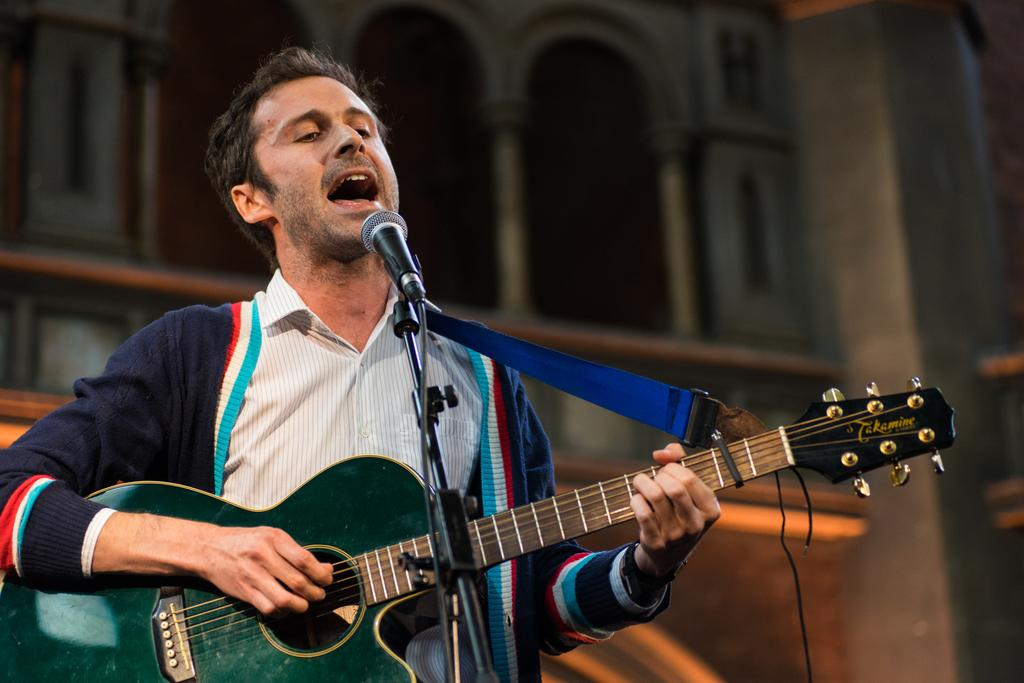Who is present in the image? There is a man in the image. What is the man holding in the image? The man is holding a guitar. What other musical equipment can be seen in the image? There is a microphone and a microphone stand in the image. What type of office furniture can be seen in the image? There is no office furniture present in the image; it features a man holding a guitar and musical equipment. How does the train appear in the image? There is no train present in the image. 